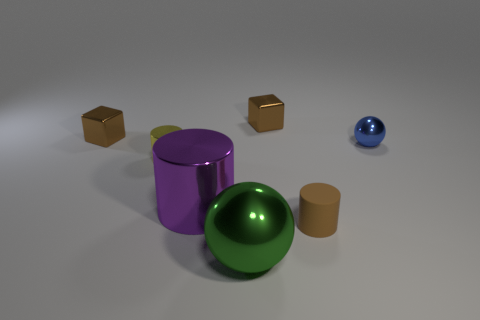Add 1 tiny objects. How many objects exist? 8 Subtract all cubes. How many objects are left? 5 Add 5 brown matte cylinders. How many brown matte cylinders are left? 6 Add 1 big objects. How many big objects exist? 3 Subtract 0 purple blocks. How many objects are left? 7 Subtract all tiny rubber cylinders. Subtract all big cylinders. How many objects are left? 5 